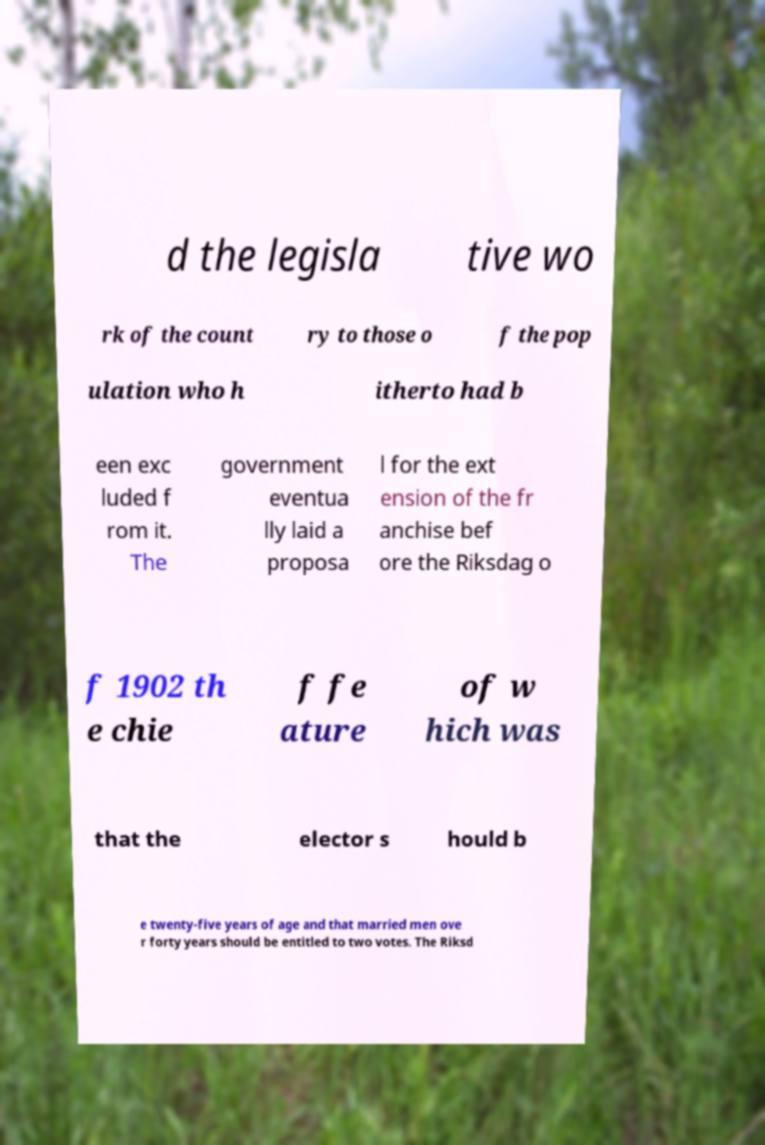I need the written content from this picture converted into text. Can you do that? d the legisla tive wo rk of the count ry to those o f the pop ulation who h itherto had b een exc luded f rom it. The government eventua lly laid a proposa l for the ext ension of the fr anchise bef ore the Riksdag o f 1902 th e chie f fe ature of w hich was that the elector s hould b e twenty-five years of age and that married men ove r forty years should be entitled to two votes. The Riksd 